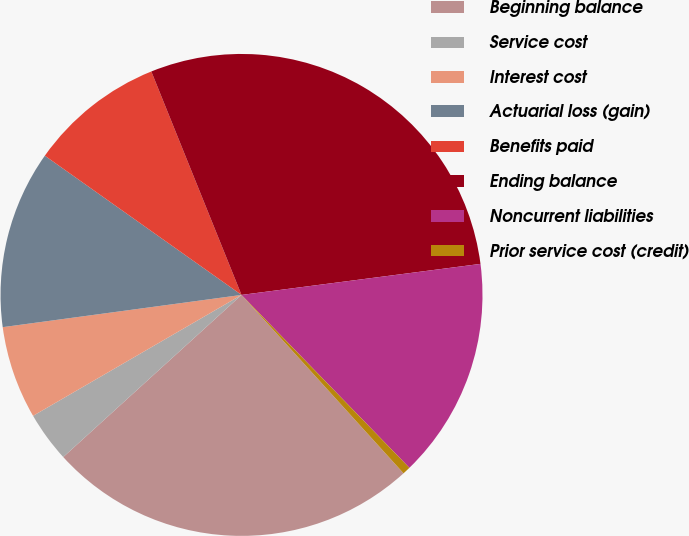Convert chart to OTSL. <chart><loc_0><loc_0><loc_500><loc_500><pie_chart><fcel>Beginning balance<fcel>Service cost<fcel>Interest cost<fcel>Actuarial loss (gain)<fcel>Benefits paid<fcel>Ending balance<fcel>Noncurrent liabilities<fcel>Prior service cost (credit)<nl><fcel>24.99%<fcel>3.38%<fcel>6.23%<fcel>11.94%<fcel>9.09%<fcel>29.05%<fcel>14.79%<fcel>0.53%<nl></chart> 